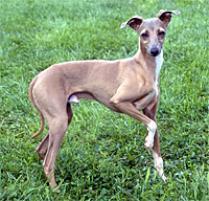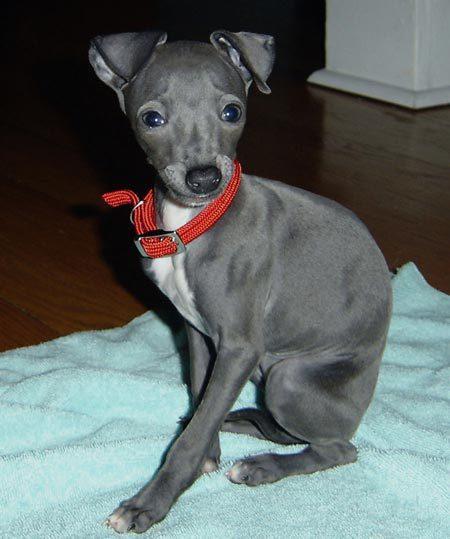The first image is the image on the left, the second image is the image on the right. Analyze the images presented: Is the assertion "Exactly one dog wears a bright red collar." valid? Answer yes or no. Yes. The first image is the image on the left, the second image is the image on the right. For the images shown, is this caption "A grayish hound with white chest marking is wearing a bright red collar." true? Answer yes or no. Yes. 